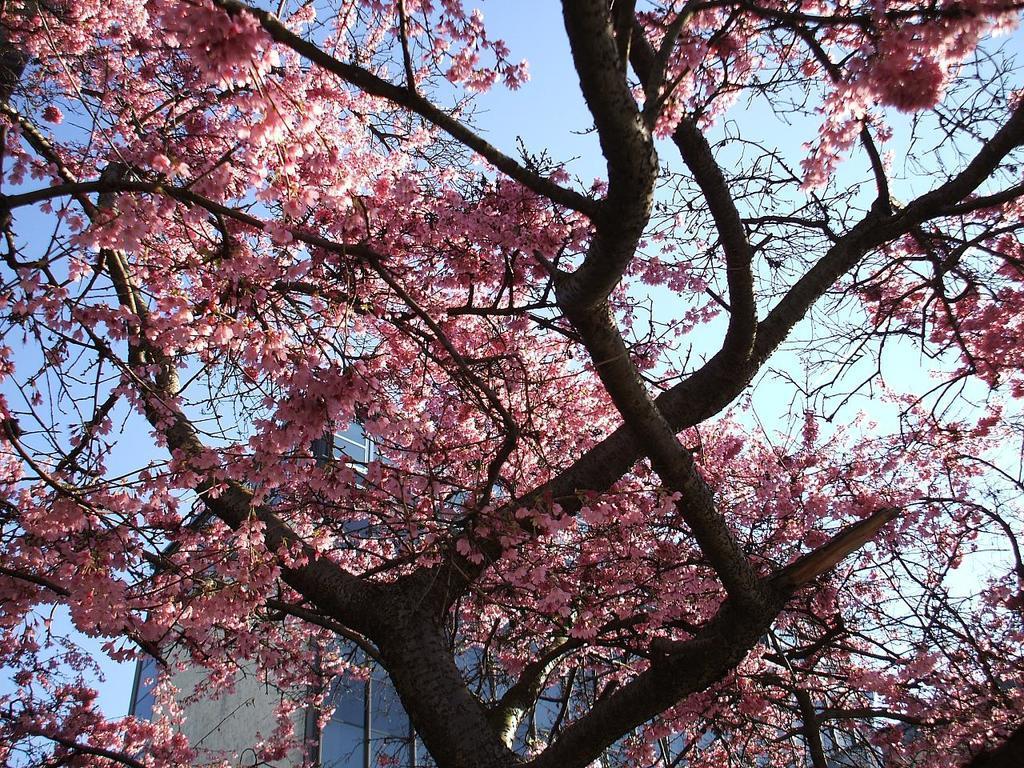Can you describe this image briefly? In this picture we can see trees with flowers and in the background we can see a building and the sky. 